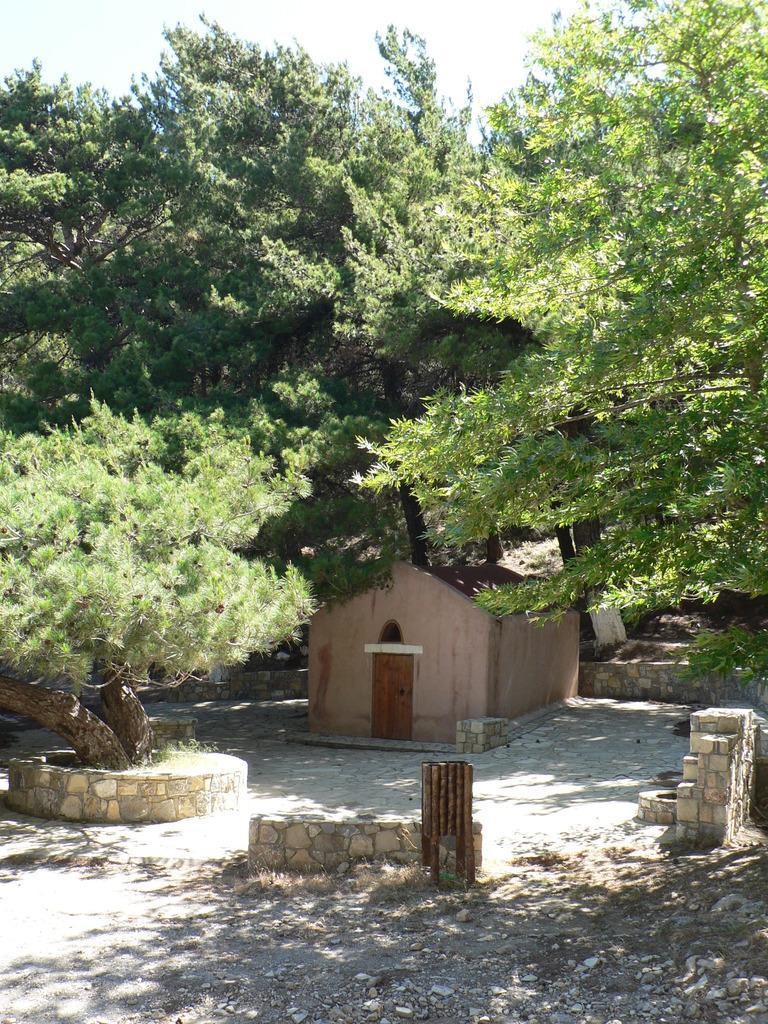Please provide a concise description of this image. In this image there is a shed and we can see trees. At the top there is sky. 